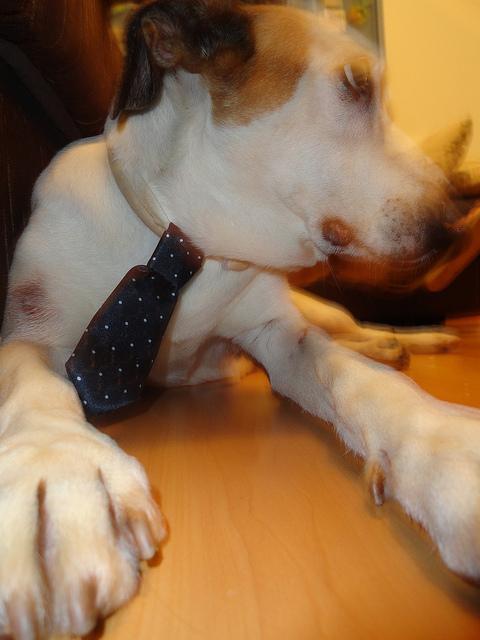How many giraffes are facing to the left?
Give a very brief answer. 0. 